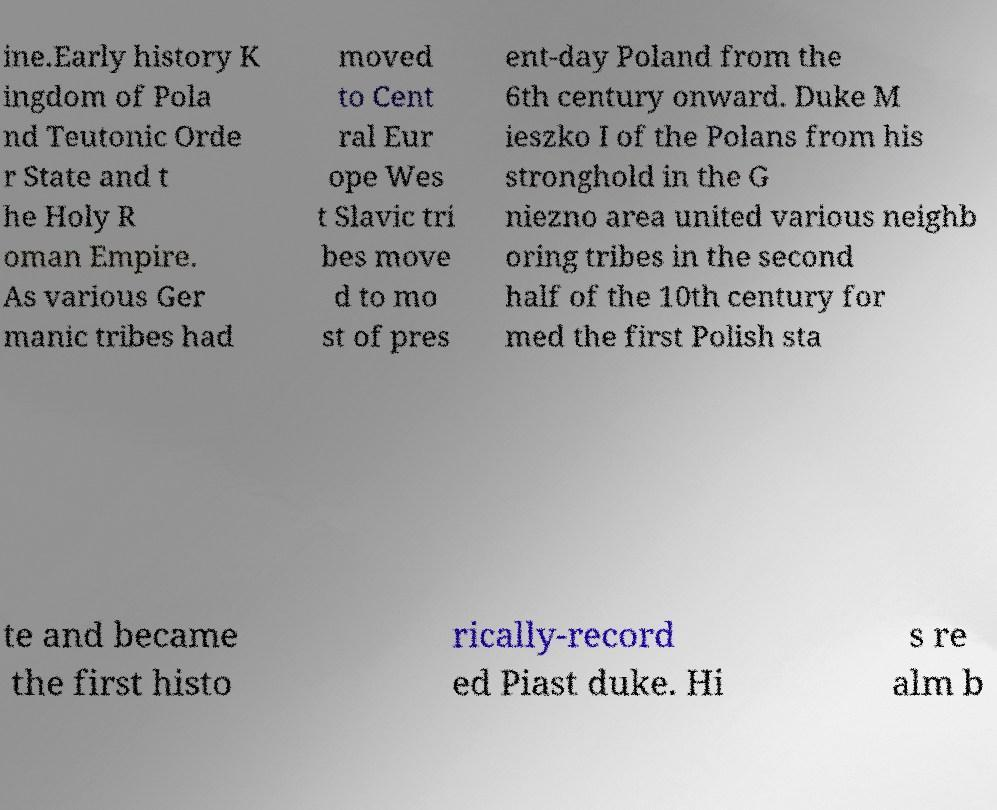Please identify and transcribe the text found in this image. ine.Early history K ingdom of Pola nd Teutonic Orde r State and t he Holy R oman Empire. As various Ger manic tribes had moved to Cent ral Eur ope Wes t Slavic tri bes move d to mo st of pres ent-day Poland from the 6th century onward. Duke M ieszko I of the Polans from his stronghold in the G niezno area united various neighb oring tribes in the second half of the 10th century for med the first Polish sta te and became the first histo rically-record ed Piast duke. Hi s re alm b 